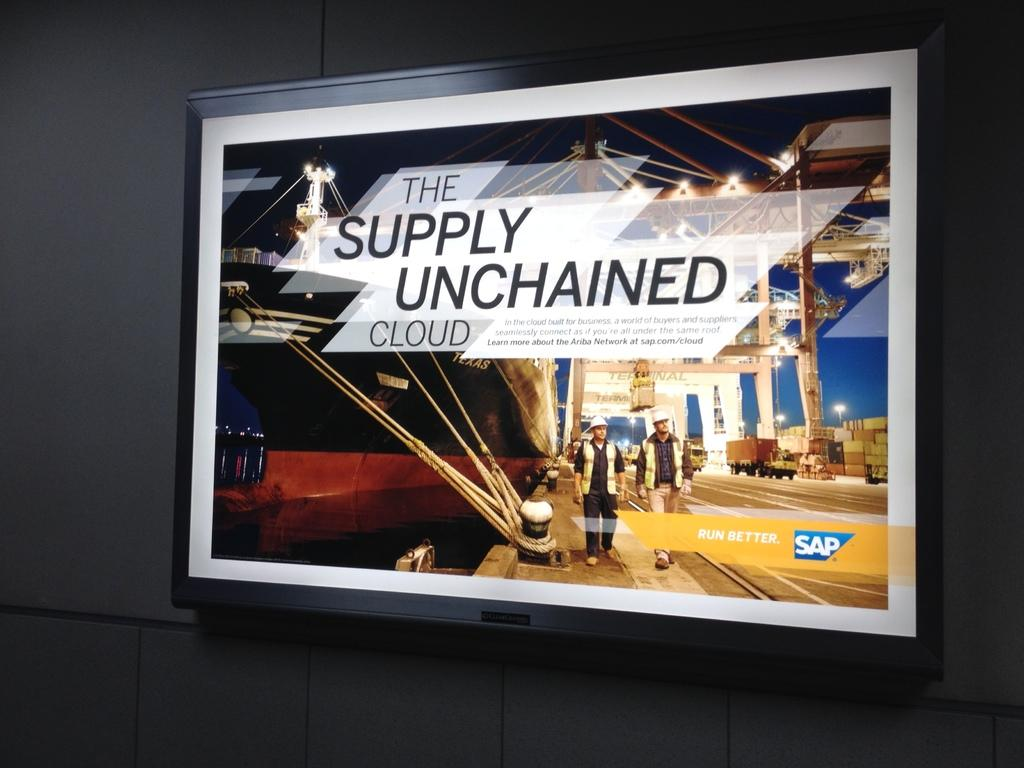<image>
Provide a brief description of the given image. A rectangular billboard with a sign for "The Supply Unchained Cloud". 